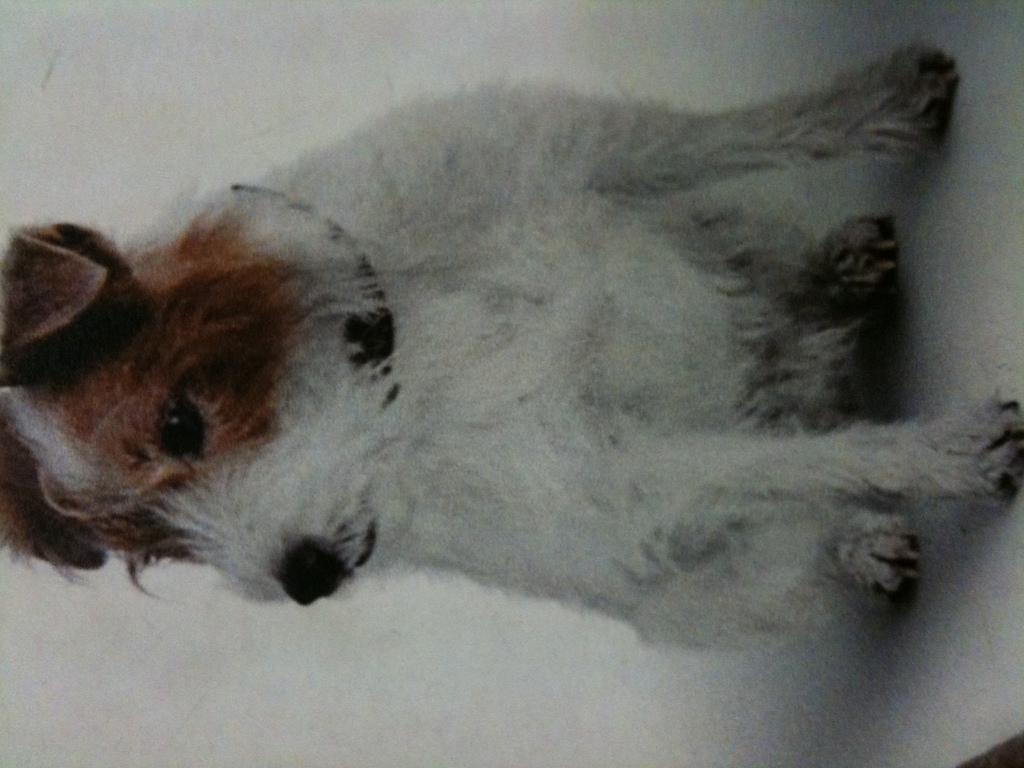What type of animal is in the image? There is a dog in the image. Where is the dog located in the image? The dog is sitting on a table. What type of face can be seen on the tomatoes in the image? There are no tomatoes present in the image, and therefore no faces can be seen on them. 